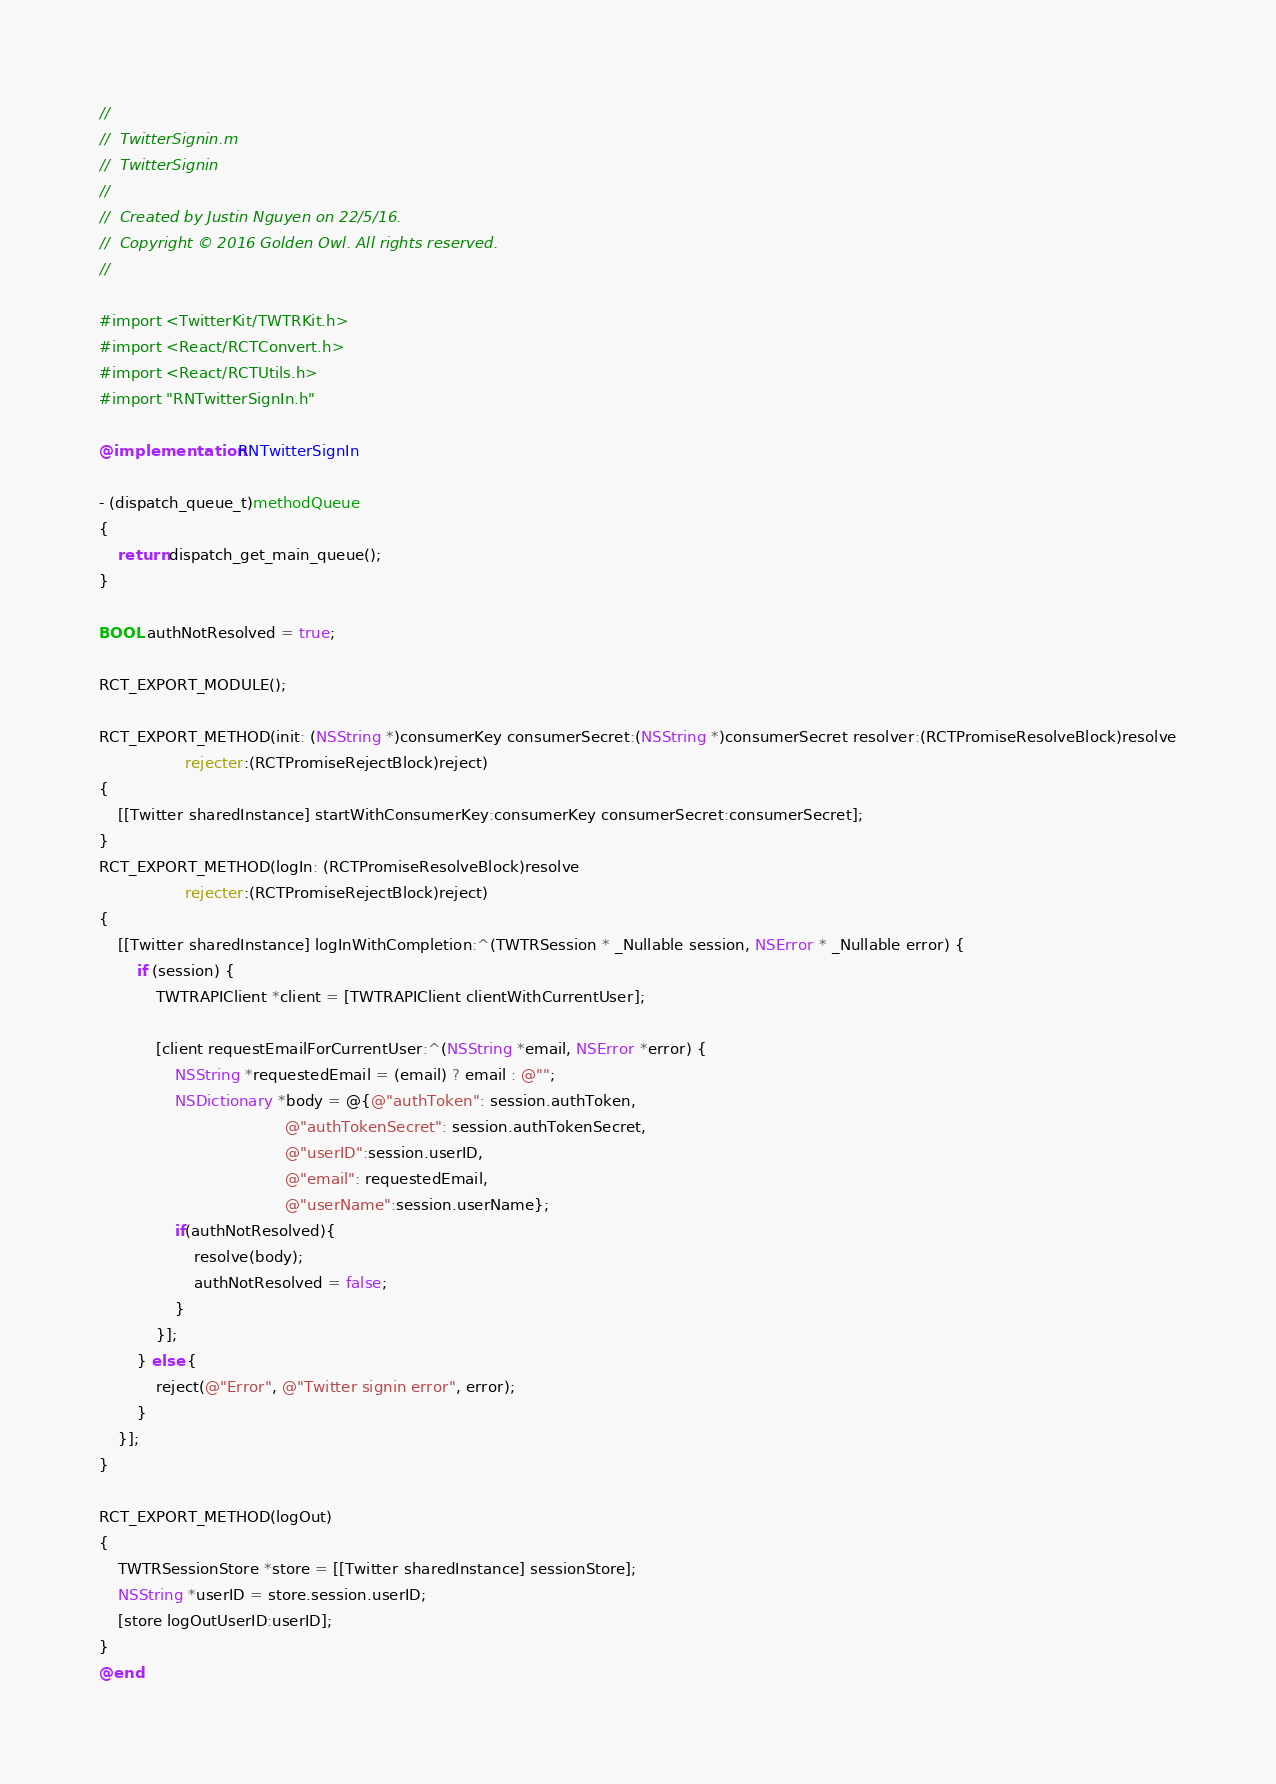<code> <loc_0><loc_0><loc_500><loc_500><_ObjectiveC_>//
//  TwitterSignin.m
//  TwitterSignin
//
//  Created by Justin Nguyen on 22/5/16.
//  Copyright © 2016 Golden Owl. All rights reserved.
//

#import <TwitterKit/TWTRKit.h>
#import <React/RCTConvert.h>
#import <React/RCTUtils.h>
#import "RNTwitterSignIn.h"

@implementation RNTwitterSignIn

- (dispatch_queue_t)methodQueue
{
    return dispatch_get_main_queue();
}

BOOL authNotResolved = true;

RCT_EXPORT_MODULE();

RCT_EXPORT_METHOD(init: (NSString *)consumerKey consumerSecret:(NSString *)consumerSecret resolver:(RCTPromiseResolveBlock)resolve
                  rejecter:(RCTPromiseRejectBlock)reject)
{
    [[Twitter sharedInstance] startWithConsumerKey:consumerKey consumerSecret:consumerSecret];
}
RCT_EXPORT_METHOD(logIn: (RCTPromiseResolveBlock)resolve
                  rejecter:(RCTPromiseRejectBlock)reject)
{
    [[Twitter sharedInstance] logInWithCompletion:^(TWTRSession * _Nullable session, NSError * _Nullable error) {
        if (session) {
            TWTRAPIClient *client = [TWTRAPIClient clientWithCurrentUser];

            [client requestEmailForCurrentUser:^(NSString *email, NSError *error) {
                NSString *requestedEmail = (email) ? email : @"";
                NSDictionary *body = @{@"authToken": session.authToken,
                                       @"authTokenSecret": session.authTokenSecret,
                                       @"userID":session.userID,
                                       @"email": requestedEmail,
                                       @"userName":session.userName};
                if(authNotResolved){
                    resolve(body);
                    authNotResolved = false;
                }
            }];
        } else {
            reject(@"Error", @"Twitter signin error", error);
        }
    }];
}

RCT_EXPORT_METHOD(logOut)
{
    TWTRSessionStore *store = [[Twitter sharedInstance] sessionStore];
    NSString *userID = store.session.userID;
    [store logOutUserID:userID];
}
@end
</code> 